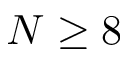Convert formula to latex. <formula><loc_0><loc_0><loc_500><loc_500>N \geq 8</formula> 